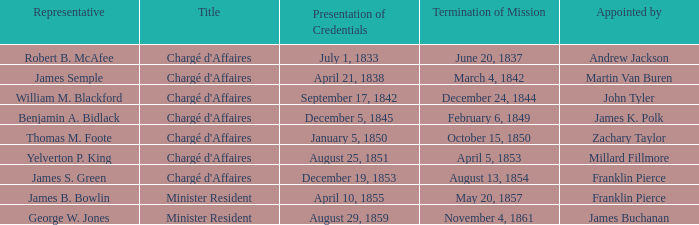What's the Representative listed that has a Presentation of Credentials of August 25, 1851? Yelverton P. King. 